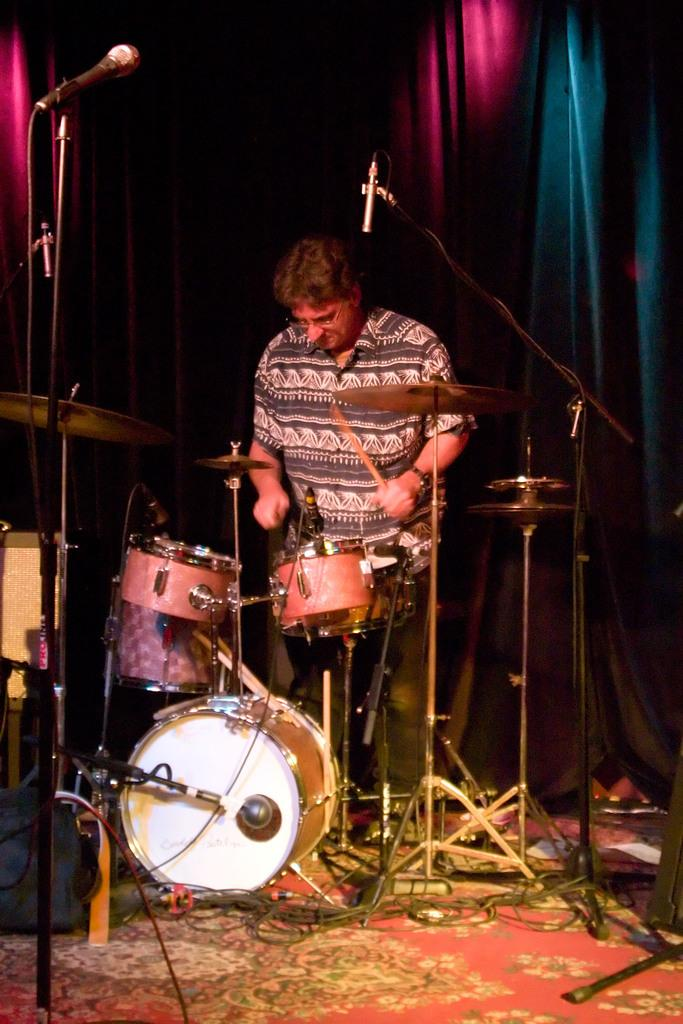What is the main subject of the image? There is a person standing in the image. What objects are related to music in the image? There are microphones, drums, and other musical instruments in the image. What can be seen in the background of the image? There are curtains in the background of the image. How many kittens are playing with a vegetable on the road in the image? There are no kittens, vegetables, or roads present in the image. 